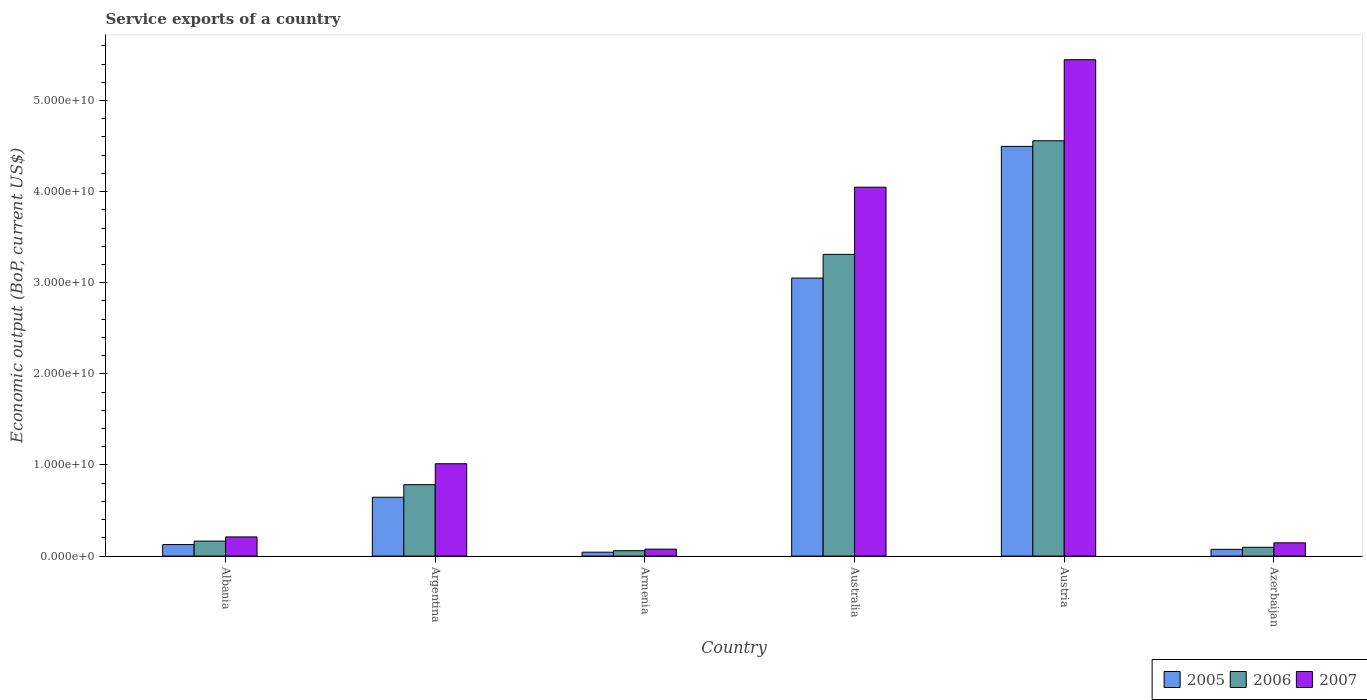Are the number of bars per tick equal to the number of legend labels?
Your response must be concise. Yes. How many bars are there on the 6th tick from the left?
Provide a short and direct response. 3. How many bars are there on the 4th tick from the right?
Your answer should be compact. 3. What is the label of the 2nd group of bars from the left?
Provide a succinct answer. Argentina. What is the service exports in 2005 in Australia?
Give a very brief answer. 3.05e+1. Across all countries, what is the maximum service exports in 2007?
Your answer should be compact. 5.45e+1. Across all countries, what is the minimum service exports in 2006?
Make the answer very short. 5.94e+08. In which country was the service exports in 2006 minimum?
Offer a very short reply. Armenia. What is the total service exports in 2006 in the graph?
Ensure brevity in your answer.  8.97e+1. What is the difference between the service exports in 2007 in Albania and that in Armenia?
Ensure brevity in your answer.  1.34e+09. What is the difference between the service exports in 2006 in Austria and the service exports in 2005 in Azerbaijan?
Give a very brief answer. 4.48e+1. What is the average service exports in 2005 per country?
Ensure brevity in your answer.  1.41e+1. What is the difference between the service exports of/in 2005 and service exports of/in 2006 in Austria?
Keep it short and to the point. -6.15e+08. In how many countries, is the service exports in 2007 greater than 28000000000 US$?
Make the answer very short. 2. What is the ratio of the service exports in 2005 in Argentina to that in Austria?
Give a very brief answer. 0.14. Is the difference between the service exports in 2005 in Albania and Argentina greater than the difference between the service exports in 2006 in Albania and Argentina?
Your answer should be very brief. Yes. What is the difference between the highest and the second highest service exports in 2005?
Provide a short and direct response. -2.40e+1. What is the difference between the highest and the lowest service exports in 2006?
Offer a terse response. 4.50e+1. In how many countries, is the service exports in 2005 greater than the average service exports in 2005 taken over all countries?
Provide a short and direct response. 2. What does the 2nd bar from the left in Azerbaijan represents?
Make the answer very short. 2006. How many countries are there in the graph?
Provide a short and direct response. 6. Does the graph contain grids?
Your answer should be very brief. No. Where does the legend appear in the graph?
Ensure brevity in your answer.  Bottom right. How many legend labels are there?
Your response must be concise. 3. How are the legend labels stacked?
Make the answer very short. Horizontal. What is the title of the graph?
Make the answer very short. Service exports of a country. What is the label or title of the Y-axis?
Your answer should be very brief. Economic output (BoP, current US$). What is the Economic output (BoP, current US$) in 2005 in Albania?
Your answer should be very brief. 1.27e+09. What is the Economic output (BoP, current US$) in 2006 in Albania?
Provide a short and direct response. 1.65e+09. What is the Economic output (BoP, current US$) in 2007 in Albania?
Ensure brevity in your answer.  2.10e+09. What is the Economic output (BoP, current US$) in 2005 in Argentina?
Provide a succinct answer. 6.46e+09. What is the Economic output (BoP, current US$) in 2006 in Argentina?
Your response must be concise. 7.84e+09. What is the Economic output (BoP, current US$) of 2007 in Argentina?
Your answer should be very brief. 1.01e+1. What is the Economic output (BoP, current US$) of 2005 in Armenia?
Offer a very short reply. 4.30e+08. What is the Economic output (BoP, current US$) of 2006 in Armenia?
Provide a short and direct response. 5.94e+08. What is the Economic output (BoP, current US$) of 2007 in Armenia?
Keep it short and to the point. 7.64e+08. What is the Economic output (BoP, current US$) in 2005 in Australia?
Offer a very short reply. 3.05e+1. What is the Economic output (BoP, current US$) of 2006 in Australia?
Your answer should be compact. 3.31e+1. What is the Economic output (BoP, current US$) of 2007 in Australia?
Your answer should be very brief. 4.05e+1. What is the Economic output (BoP, current US$) of 2005 in Austria?
Provide a succinct answer. 4.50e+1. What is the Economic output (BoP, current US$) of 2006 in Austria?
Offer a very short reply. 4.56e+1. What is the Economic output (BoP, current US$) in 2007 in Austria?
Offer a very short reply. 5.45e+1. What is the Economic output (BoP, current US$) of 2005 in Azerbaijan?
Provide a short and direct response. 7.41e+08. What is the Economic output (BoP, current US$) of 2006 in Azerbaijan?
Give a very brief answer. 9.65e+08. What is the Economic output (BoP, current US$) in 2007 in Azerbaijan?
Keep it short and to the point. 1.46e+09. Across all countries, what is the maximum Economic output (BoP, current US$) in 2005?
Offer a very short reply. 4.50e+1. Across all countries, what is the maximum Economic output (BoP, current US$) in 2006?
Your answer should be compact. 4.56e+1. Across all countries, what is the maximum Economic output (BoP, current US$) in 2007?
Keep it short and to the point. 5.45e+1. Across all countries, what is the minimum Economic output (BoP, current US$) of 2005?
Your answer should be very brief. 4.30e+08. Across all countries, what is the minimum Economic output (BoP, current US$) in 2006?
Provide a succinct answer. 5.94e+08. Across all countries, what is the minimum Economic output (BoP, current US$) in 2007?
Provide a succinct answer. 7.64e+08. What is the total Economic output (BoP, current US$) of 2005 in the graph?
Keep it short and to the point. 8.44e+1. What is the total Economic output (BoP, current US$) in 2006 in the graph?
Make the answer very short. 8.97e+1. What is the total Economic output (BoP, current US$) of 2007 in the graph?
Offer a very short reply. 1.09e+11. What is the difference between the Economic output (BoP, current US$) of 2005 in Albania and that in Argentina?
Keep it short and to the point. -5.19e+09. What is the difference between the Economic output (BoP, current US$) of 2006 in Albania and that in Argentina?
Give a very brief answer. -6.19e+09. What is the difference between the Economic output (BoP, current US$) in 2007 in Albania and that in Argentina?
Keep it short and to the point. -8.03e+09. What is the difference between the Economic output (BoP, current US$) in 2005 in Albania and that in Armenia?
Provide a succinct answer. 8.37e+08. What is the difference between the Economic output (BoP, current US$) of 2006 in Albania and that in Armenia?
Give a very brief answer. 1.05e+09. What is the difference between the Economic output (BoP, current US$) in 2007 in Albania and that in Armenia?
Ensure brevity in your answer.  1.34e+09. What is the difference between the Economic output (BoP, current US$) of 2005 in Albania and that in Australia?
Offer a very short reply. -2.92e+1. What is the difference between the Economic output (BoP, current US$) in 2006 in Albania and that in Australia?
Provide a short and direct response. -3.15e+1. What is the difference between the Economic output (BoP, current US$) in 2007 in Albania and that in Australia?
Offer a terse response. -3.84e+1. What is the difference between the Economic output (BoP, current US$) of 2005 in Albania and that in Austria?
Keep it short and to the point. -4.37e+1. What is the difference between the Economic output (BoP, current US$) of 2006 in Albania and that in Austria?
Your answer should be compact. -4.39e+1. What is the difference between the Economic output (BoP, current US$) in 2007 in Albania and that in Austria?
Offer a terse response. -5.24e+1. What is the difference between the Economic output (BoP, current US$) in 2005 in Albania and that in Azerbaijan?
Your response must be concise. 5.25e+08. What is the difference between the Economic output (BoP, current US$) in 2006 in Albania and that in Azerbaijan?
Keep it short and to the point. 6.81e+08. What is the difference between the Economic output (BoP, current US$) of 2007 in Albania and that in Azerbaijan?
Provide a short and direct response. 6.49e+08. What is the difference between the Economic output (BoP, current US$) of 2005 in Argentina and that in Armenia?
Make the answer very short. 6.03e+09. What is the difference between the Economic output (BoP, current US$) in 2006 in Argentina and that in Armenia?
Give a very brief answer. 7.24e+09. What is the difference between the Economic output (BoP, current US$) in 2007 in Argentina and that in Armenia?
Your answer should be very brief. 9.37e+09. What is the difference between the Economic output (BoP, current US$) of 2005 in Argentina and that in Australia?
Your answer should be very brief. -2.40e+1. What is the difference between the Economic output (BoP, current US$) in 2006 in Argentina and that in Australia?
Provide a short and direct response. -2.53e+1. What is the difference between the Economic output (BoP, current US$) in 2007 in Argentina and that in Australia?
Ensure brevity in your answer.  -3.03e+1. What is the difference between the Economic output (BoP, current US$) of 2005 in Argentina and that in Austria?
Keep it short and to the point. -3.85e+1. What is the difference between the Economic output (BoP, current US$) of 2006 in Argentina and that in Austria?
Provide a succinct answer. -3.77e+1. What is the difference between the Economic output (BoP, current US$) of 2007 in Argentina and that in Austria?
Make the answer very short. -4.43e+1. What is the difference between the Economic output (BoP, current US$) of 2005 in Argentina and that in Azerbaijan?
Provide a succinct answer. 5.72e+09. What is the difference between the Economic output (BoP, current US$) in 2006 in Argentina and that in Azerbaijan?
Ensure brevity in your answer.  6.87e+09. What is the difference between the Economic output (BoP, current US$) in 2007 in Argentina and that in Azerbaijan?
Keep it short and to the point. 8.68e+09. What is the difference between the Economic output (BoP, current US$) in 2005 in Armenia and that in Australia?
Your response must be concise. -3.01e+1. What is the difference between the Economic output (BoP, current US$) in 2006 in Armenia and that in Australia?
Provide a short and direct response. -3.25e+1. What is the difference between the Economic output (BoP, current US$) of 2007 in Armenia and that in Australia?
Give a very brief answer. -3.97e+1. What is the difference between the Economic output (BoP, current US$) in 2005 in Armenia and that in Austria?
Keep it short and to the point. -4.45e+1. What is the difference between the Economic output (BoP, current US$) of 2006 in Armenia and that in Austria?
Make the answer very short. -4.50e+1. What is the difference between the Economic output (BoP, current US$) of 2007 in Armenia and that in Austria?
Give a very brief answer. -5.37e+1. What is the difference between the Economic output (BoP, current US$) in 2005 in Armenia and that in Azerbaijan?
Make the answer very short. -3.11e+08. What is the difference between the Economic output (BoP, current US$) in 2006 in Armenia and that in Azerbaijan?
Provide a succinct answer. -3.72e+08. What is the difference between the Economic output (BoP, current US$) of 2007 in Armenia and that in Azerbaijan?
Ensure brevity in your answer.  -6.91e+08. What is the difference between the Economic output (BoP, current US$) of 2005 in Australia and that in Austria?
Your answer should be very brief. -1.45e+1. What is the difference between the Economic output (BoP, current US$) of 2006 in Australia and that in Austria?
Provide a succinct answer. -1.25e+1. What is the difference between the Economic output (BoP, current US$) of 2007 in Australia and that in Austria?
Provide a succinct answer. -1.40e+1. What is the difference between the Economic output (BoP, current US$) of 2005 in Australia and that in Azerbaijan?
Provide a short and direct response. 2.98e+1. What is the difference between the Economic output (BoP, current US$) of 2006 in Australia and that in Azerbaijan?
Give a very brief answer. 3.21e+1. What is the difference between the Economic output (BoP, current US$) in 2007 in Australia and that in Azerbaijan?
Provide a short and direct response. 3.90e+1. What is the difference between the Economic output (BoP, current US$) in 2005 in Austria and that in Azerbaijan?
Provide a short and direct response. 4.42e+1. What is the difference between the Economic output (BoP, current US$) in 2006 in Austria and that in Azerbaijan?
Give a very brief answer. 4.46e+1. What is the difference between the Economic output (BoP, current US$) in 2007 in Austria and that in Azerbaijan?
Give a very brief answer. 5.30e+1. What is the difference between the Economic output (BoP, current US$) of 2005 in Albania and the Economic output (BoP, current US$) of 2006 in Argentina?
Keep it short and to the point. -6.57e+09. What is the difference between the Economic output (BoP, current US$) in 2005 in Albania and the Economic output (BoP, current US$) in 2007 in Argentina?
Ensure brevity in your answer.  -8.87e+09. What is the difference between the Economic output (BoP, current US$) in 2006 in Albania and the Economic output (BoP, current US$) in 2007 in Argentina?
Offer a terse response. -8.49e+09. What is the difference between the Economic output (BoP, current US$) in 2005 in Albania and the Economic output (BoP, current US$) in 2006 in Armenia?
Give a very brief answer. 6.73e+08. What is the difference between the Economic output (BoP, current US$) of 2005 in Albania and the Economic output (BoP, current US$) of 2007 in Armenia?
Offer a very short reply. 5.02e+08. What is the difference between the Economic output (BoP, current US$) of 2006 in Albania and the Economic output (BoP, current US$) of 2007 in Armenia?
Provide a succinct answer. 8.82e+08. What is the difference between the Economic output (BoP, current US$) of 2005 in Albania and the Economic output (BoP, current US$) of 2006 in Australia?
Give a very brief answer. -3.18e+1. What is the difference between the Economic output (BoP, current US$) of 2005 in Albania and the Economic output (BoP, current US$) of 2007 in Australia?
Your answer should be very brief. -3.92e+1. What is the difference between the Economic output (BoP, current US$) of 2006 in Albania and the Economic output (BoP, current US$) of 2007 in Australia?
Provide a succinct answer. -3.88e+1. What is the difference between the Economic output (BoP, current US$) of 2005 in Albania and the Economic output (BoP, current US$) of 2006 in Austria?
Provide a short and direct response. -4.43e+1. What is the difference between the Economic output (BoP, current US$) of 2005 in Albania and the Economic output (BoP, current US$) of 2007 in Austria?
Ensure brevity in your answer.  -5.32e+1. What is the difference between the Economic output (BoP, current US$) in 2006 in Albania and the Economic output (BoP, current US$) in 2007 in Austria?
Your response must be concise. -5.28e+1. What is the difference between the Economic output (BoP, current US$) in 2005 in Albania and the Economic output (BoP, current US$) in 2006 in Azerbaijan?
Give a very brief answer. 3.01e+08. What is the difference between the Economic output (BoP, current US$) of 2005 in Albania and the Economic output (BoP, current US$) of 2007 in Azerbaijan?
Give a very brief answer. -1.89e+08. What is the difference between the Economic output (BoP, current US$) in 2006 in Albania and the Economic output (BoP, current US$) in 2007 in Azerbaijan?
Offer a very short reply. 1.91e+08. What is the difference between the Economic output (BoP, current US$) of 2005 in Argentina and the Economic output (BoP, current US$) of 2006 in Armenia?
Give a very brief answer. 5.86e+09. What is the difference between the Economic output (BoP, current US$) of 2005 in Argentina and the Economic output (BoP, current US$) of 2007 in Armenia?
Provide a succinct answer. 5.69e+09. What is the difference between the Economic output (BoP, current US$) of 2006 in Argentina and the Economic output (BoP, current US$) of 2007 in Armenia?
Your answer should be compact. 7.07e+09. What is the difference between the Economic output (BoP, current US$) in 2005 in Argentina and the Economic output (BoP, current US$) in 2006 in Australia?
Keep it short and to the point. -2.66e+1. What is the difference between the Economic output (BoP, current US$) of 2005 in Argentina and the Economic output (BoP, current US$) of 2007 in Australia?
Your answer should be compact. -3.40e+1. What is the difference between the Economic output (BoP, current US$) of 2006 in Argentina and the Economic output (BoP, current US$) of 2007 in Australia?
Make the answer very short. -3.26e+1. What is the difference between the Economic output (BoP, current US$) of 2005 in Argentina and the Economic output (BoP, current US$) of 2006 in Austria?
Ensure brevity in your answer.  -3.91e+1. What is the difference between the Economic output (BoP, current US$) of 2005 in Argentina and the Economic output (BoP, current US$) of 2007 in Austria?
Give a very brief answer. -4.80e+1. What is the difference between the Economic output (BoP, current US$) in 2006 in Argentina and the Economic output (BoP, current US$) in 2007 in Austria?
Offer a very short reply. -4.66e+1. What is the difference between the Economic output (BoP, current US$) in 2005 in Argentina and the Economic output (BoP, current US$) in 2006 in Azerbaijan?
Your response must be concise. 5.49e+09. What is the difference between the Economic output (BoP, current US$) in 2005 in Argentina and the Economic output (BoP, current US$) in 2007 in Azerbaijan?
Your answer should be compact. 5.00e+09. What is the difference between the Economic output (BoP, current US$) in 2006 in Argentina and the Economic output (BoP, current US$) in 2007 in Azerbaijan?
Make the answer very short. 6.38e+09. What is the difference between the Economic output (BoP, current US$) in 2005 in Armenia and the Economic output (BoP, current US$) in 2006 in Australia?
Provide a succinct answer. -3.27e+1. What is the difference between the Economic output (BoP, current US$) of 2005 in Armenia and the Economic output (BoP, current US$) of 2007 in Australia?
Make the answer very short. -4.01e+1. What is the difference between the Economic output (BoP, current US$) of 2006 in Armenia and the Economic output (BoP, current US$) of 2007 in Australia?
Provide a short and direct response. -3.99e+1. What is the difference between the Economic output (BoP, current US$) in 2005 in Armenia and the Economic output (BoP, current US$) in 2006 in Austria?
Your answer should be compact. -4.51e+1. What is the difference between the Economic output (BoP, current US$) in 2005 in Armenia and the Economic output (BoP, current US$) in 2007 in Austria?
Give a very brief answer. -5.40e+1. What is the difference between the Economic output (BoP, current US$) of 2006 in Armenia and the Economic output (BoP, current US$) of 2007 in Austria?
Keep it short and to the point. -5.39e+1. What is the difference between the Economic output (BoP, current US$) in 2005 in Armenia and the Economic output (BoP, current US$) in 2006 in Azerbaijan?
Your response must be concise. -5.35e+08. What is the difference between the Economic output (BoP, current US$) of 2005 in Armenia and the Economic output (BoP, current US$) of 2007 in Azerbaijan?
Offer a terse response. -1.03e+09. What is the difference between the Economic output (BoP, current US$) of 2006 in Armenia and the Economic output (BoP, current US$) of 2007 in Azerbaijan?
Offer a very short reply. -8.62e+08. What is the difference between the Economic output (BoP, current US$) in 2005 in Australia and the Economic output (BoP, current US$) in 2006 in Austria?
Provide a succinct answer. -1.51e+1. What is the difference between the Economic output (BoP, current US$) of 2005 in Australia and the Economic output (BoP, current US$) of 2007 in Austria?
Provide a short and direct response. -2.40e+1. What is the difference between the Economic output (BoP, current US$) in 2006 in Australia and the Economic output (BoP, current US$) in 2007 in Austria?
Provide a short and direct response. -2.14e+1. What is the difference between the Economic output (BoP, current US$) of 2005 in Australia and the Economic output (BoP, current US$) of 2006 in Azerbaijan?
Make the answer very short. 2.95e+1. What is the difference between the Economic output (BoP, current US$) in 2005 in Australia and the Economic output (BoP, current US$) in 2007 in Azerbaijan?
Provide a succinct answer. 2.91e+1. What is the difference between the Economic output (BoP, current US$) of 2006 in Australia and the Economic output (BoP, current US$) of 2007 in Azerbaijan?
Provide a succinct answer. 3.17e+1. What is the difference between the Economic output (BoP, current US$) of 2005 in Austria and the Economic output (BoP, current US$) of 2006 in Azerbaijan?
Your response must be concise. 4.40e+1. What is the difference between the Economic output (BoP, current US$) in 2005 in Austria and the Economic output (BoP, current US$) in 2007 in Azerbaijan?
Provide a succinct answer. 4.35e+1. What is the difference between the Economic output (BoP, current US$) in 2006 in Austria and the Economic output (BoP, current US$) in 2007 in Azerbaijan?
Your response must be concise. 4.41e+1. What is the average Economic output (BoP, current US$) of 2005 per country?
Make the answer very short. 1.41e+1. What is the average Economic output (BoP, current US$) of 2006 per country?
Offer a terse response. 1.50e+1. What is the average Economic output (BoP, current US$) of 2007 per country?
Your answer should be very brief. 1.82e+1. What is the difference between the Economic output (BoP, current US$) in 2005 and Economic output (BoP, current US$) in 2006 in Albania?
Provide a succinct answer. -3.79e+08. What is the difference between the Economic output (BoP, current US$) in 2005 and Economic output (BoP, current US$) in 2007 in Albania?
Make the answer very short. -8.38e+08. What is the difference between the Economic output (BoP, current US$) in 2006 and Economic output (BoP, current US$) in 2007 in Albania?
Provide a succinct answer. -4.59e+08. What is the difference between the Economic output (BoP, current US$) in 2005 and Economic output (BoP, current US$) in 2006 in Argentina?
Give a very brief answer. -1.38e+09. What is the difference between the Economic output (BoP, current US$) of 2005 and Economic output (BoP, current US$) of 2007 in Argentina?
Ensure brevity in your answer.  -3.68e+09. What is the difference between the Economic output (BoP, current US$) of 2006 and Economic output (BoP, current US$) of 2007 in Argentina?
Your response must be concise. -2.30e+09. What is the difference between the Economic output (BoP, current US$) in 2005 and Economic output (BoP, current US$) in 2006 in Armenia?
Offer a terse response. -1.64e+08. What is the difference between the Economic output (BoP, current US$) in 2005 and Economic output (BoP, current US$) in 2007 in Armenia?
Provide a succinct answer. -3.34e+08. What is the difference between the Economic output (BoP, current US$) in 2006 and Economic output (BoP, current US$) in 2007 in Armenia?
Offer a terse response. -1.70e+08. What is the difference between the Economic output (BoP, current US$) of 2005 and Economic output (BoP, current US$) of 2006 in Australia?
Provide a short and direct response. -2.60e+09. What is the difference between the Economic output (BoP, current US$) in 2005 and Economic output (BoP, current US$) in 2007 in Australia?
Offer a very short reply. -9.97e+09. What is the difference between the Economic output (BoP, current US$) in 2006 and Economic output (BoP, current US$) in 2007 in Australia?
Provide a short and direct response. -7.37e+09. What is the difference between the Economic output (BoP, current US$) of 2005 and Economic output (BoP, current US$) of 2006 in Austria?
Provide a short and direct response. -6.15e+08. What is the difference between the Economic output (BoP, current US$) of 2005 and Economic output (BoP, current US$) of 2007 in Austria?
Your answer should be very brief. -9.51e+09. What is the difference between the Economic output (BoP, current US$) in 2006 and Economic output (BoP, current US$) in 2007 in Austria?
Provide a succinct answer. -8.90e+09. What is the difference between the Economic output (BoP, current US$) of 2005 and Economic output (BoP, current US$) of 2006 in Azerbaijan?
Keep it short and to the point. -2.24e+08. What is the difference between the Economic output (BoP, current US$) in 2005 and Economic output (BoP, current US$) in 2007 in Azerbaijan?
Provide a succinct answer. -7.14e+08. What is the difference between the Economic output (BoP, current US$) of 2006 and Economic output (BoP, current US$) of 2007 in Azerbaijan?
Offer a terse response. -4.90e+08. What is the ratio of the Economic output (BoP, current US$) of 2005 in Albania to that in Argentina?
Provide a succinct answer. 0.2. What is the ratio of the Economic output (BoP, current US$) in 2006 in Albania to that in Argentina?
Keep it short and to the point. 0.21. What is the ratio of the Economic output (BoP, current US$) of 2007 in Albania to that in Argentina?
Give a very brief answer. 0.21. What is the ratio of the Economic output (BoP, current US$) of 2005 in Albania to that in Armenia?
Make the answer very short. 2.94. What is the ratio of the Economic output (BoP, current US$) in 2006 in Albania to that in Armenia?
Your response must be concise. 2.77. What is the ratio of the Economic output (BoP, current US$) in 2007 in Albania to that in Armenia?
Keep it short and to the point. 2.75. What is the ratio of the Economic output (BoP, current US$) in 2005 in Albania to that in Australia?
Your answer should be compact. 0.04. What is the ratio of the Economic output (BoP, current US$) in 2006 in Albania to that in Australia?
Your answer should be very brief. 0.05. What is the ratio of the Economic output (BoP, current US$) in 2007 in Albania to that in Australia?
Offer a terse response. 0.05. What is the ratio of the Economic output (BoP, current US$) in 2005 in Albania to that in Austria?
Offer a terse response. 0.03. What is the ratio of the Economic output (BoP, current US$) of 2006 in Albania to that in Austria?
Provide a succinct answer. 0.04. What is the ratio of the Economic output (BoP, current US$) of 2007 in Albania to that in Austria?
Keep it short and to the point. 0.04. What is the ratio of the Economic output (BoP, current US$) of 2005 in Albania to that in Azerbaijan?
Provide a short and direct response. 1.71. What is the ratio of the Economic output (BoP, current US$) of 2006 in Albania to that in Azerbaijan?
Ensure brevity in your answer.  1.71. What is the ratio of the Economic output (BoP, current US$) of 2007 in Albania to that in Azerbaijan?
Offer a terse response. 1.45. What is the ratio of the Economic output (BoP, current US$) in 2005 in Argentina to that in Armenia?
Give a very brief answer. 15.01. What is the ratio of the Economic output (BoP, current US$) in 2006 in Argentina to that in Armenia?
Keep it short and to the point. 13.2. What is the ratio of the Economic output (BoP, current US$) in 2007 in Argentina to that in Armenia?
Your response must be concise. 13.26. What is the ratio of the Economic output (BoP, current US$) of 2005 in Argentina to that in Australia?
Provide a succinct answer. 0.21. What is the ratio of the Economic output (BoP, current US$) in 2006 in Argentina to that in Australia?
Keep it short and to the point. 0.24. What is the ratio of the Economic output (BoP, current US$) in 2007 in Argentina to that in Australia?
Make the answer very short. 0.25. What is the ratio of the Economic output (BoP, current US$) of 2005 in Argentina to that in Austria?
Keep it short and to the point. 0.14. What is the ratio of the Economic output (BoP, current US$) of 2006 in Argentina to that in Austria?
Offer a very short reply. 0.17. What is the ratio of the Economic output (BoP, current US$) of 2007 in Argentina to that in Austria?
Ensure brevity in your answer.  0.19. What is the ratio of the Economic output (BoP, current US$) of 2005 in Argentina to that in Azerbaijan?
Provide a succinct answer. 8.71. What is the ratio of the Economic output (BoP, current US$) of 2006 in Argentina to that in Azerbaijan?
Offer a very short reply. 8.12. What is the ratio of the Economic output (BoP, current US$) in 2007 in Argentina to that in Azerbaijan?
Your answer should be very brief. 6.96. What is the ratio of the Economic output (BoP, current US$) of 2005 in Armenia to that in Australia?
Your answer should be very brief. 0.01. What is the ratio of the Economic output (BoP, current US$) in 2006 in Armenia to that in Australia?
Provide a succinct answer. 0.02. What is the ratio of the Economic output (BoP, current US$) in 2007 in Armenia to that in Australia?
Ensure brevity in your answer.  0.02. What is the ratio of the Economic output (BoP, current US$) in 2005 in Armenia to that in Austria?
Ensure brevity in your answer.  0.01. What is the ratio of the Economic output (BoP, current US$) in 2006 in Armenia to that in Austria?
Keep it short and to the point. 0.01. What is the ratio of the Economic output (BoP, current US$) of 2007 in Armenia to that in Austria?
Offer a terse response. 0.01. What is the ratio of the Economic output (BoP, current US$) in 2005 in Armenia to that in Azerbaijan?
Give a very brief answer. 0.58. What is the ratio of the Economic output (BoP, current US$) in 2006 in Armenia to that in Azerbaijan?
Ensure brevity in your answer.  0.62. What is the ratio of the Economic output (BoP, current US$) in 2007 in Armenia to that in Azerbaijan?
Keep it short and to the point. 0.53. What is the ratio of the Economic output (BoP, current US$) of 2005 in Australia to that in Austria?
Your answer should be compact. 0.68. What is the ratio of the Economic output (BoP, current US$) in 2006 in Australia to that in Austria?
Offer a very short reply. 0.73. What is the ratio of the Economic output (BoP, current US$) of 2007 in Australia to that in Austria?
Your answer should be very brief. 0.74. What is the ratio of the Economic output (BoP, current US$) in 2005 in Australia to that in Azerbaijan?
Ensure brevity in your answer.  41.14. What is the ratio of the Economic output (BoP, current US$) of 2006 in Australia to that in Azerbaijan?
Offer a terse response. 34.3. What is the ratio of the Economic output (BoP, current US$) of 2007 in Australia to that in Azerbaijan?
Make the answer very short. 27.81. What is the ratio of the Economic output (BoP, current US$) in 2005 in Austria to that in Azerbaijan?
Ensure brevity in your answer.  60.64. What is the ratio of the Economic output (BoP, current US$) in 2006 in Austria to that in Azerbaijan?
Your response must be concise. 47.21. What is the ratio of the Economic output (BoP, current US$) in 2007 in Austria to that in Azerbaijan?
Give a very brief answer. 37.43. What is the difference between the highest and the second highest Economic output (BoP, current US$) in 2005?
Make the answer very short. 1.45e+1. What is the difference between the highest and the second highest Economic output (BoP, current US$) of 2006?
Your answer should be very brief. 1.25e+1. What is the difference between the highest and the second highest Economic output (BoP, current US$) in 2007?
Offer a terse response. 1.40e+1. What is the difference between the highest and the lowest Economic output (BoP, current US$) in 2005?
Your response must be concise. 4.45e+1. What is the difference between the highest and the lowest Economic output (BoP, current US$) of 2006?
Give a very brief answer. 4.50e+1. What is the difference between the highest and the lowest Economic output (BoP, current US$) of 2007?
Your answer should be very brief. 5.37e+1. 